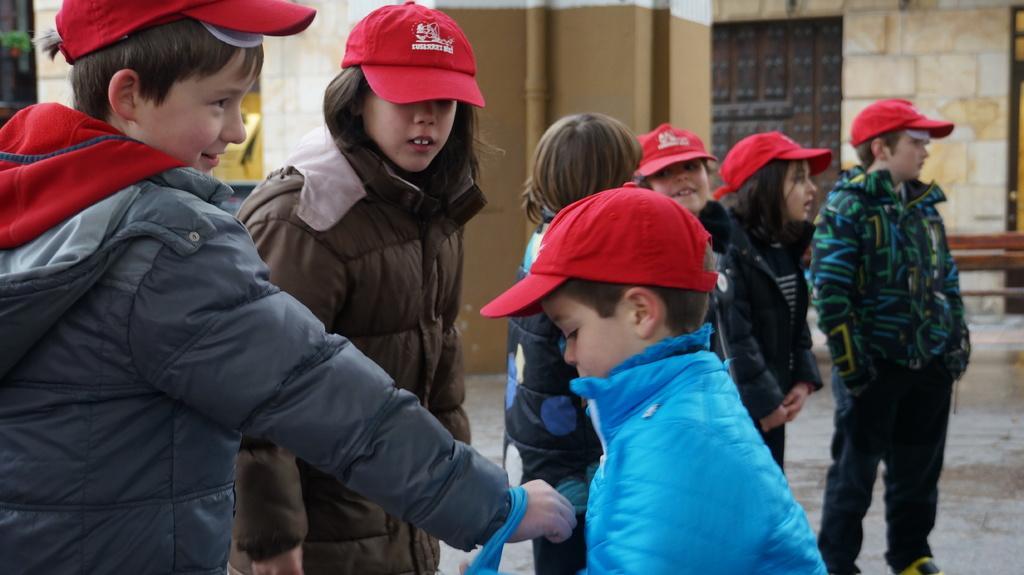In one or two sentences, can you explain what this image depicts? In this image there are kids on the floor. They are wearing jackets. Few kids are wearing the caps. Background there is a wall. Right side there is a bench on the floor. 